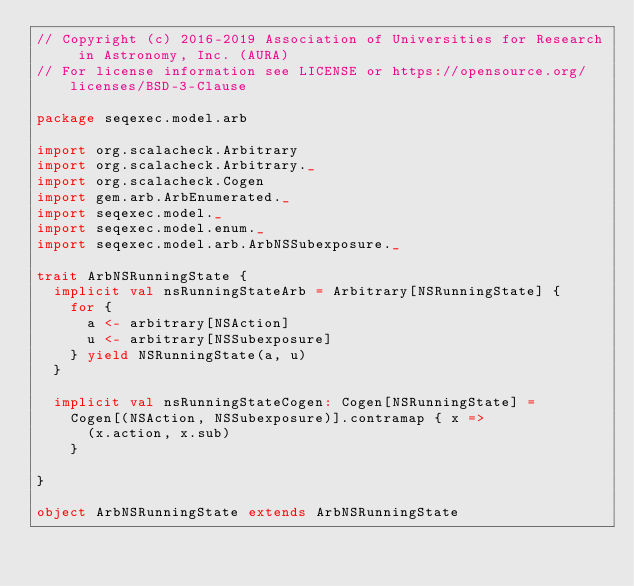Convert code to text. <code><loc_0><loc_0><loc_500><loc_500><_Scala_>// Copyright (c) 2016-2019 Association of Universities for Research in Astronomy, Inc. (AURA)
// For license information see LICENSE or https://opensource.org/licenses/BSD-3-Clause

package seqexec.model.arb

import org.scalacheck.Arbitrary
import org.scalacheck.Arbitrary._
import org.scalacheck.Cogen
import gem.arb.ArbEnumerated._
import seqexec.model._
import seqexec.model.enum._
import seqexec.model.arb.ArbNSSubexposure._

trait ArbNSRunningState {
  implicit val nsRunningStateArb = Arbitrary[NSRunningState] {
    for {
      a <- arbitrary[NSAction]
      u <- arbitrary[NSSubexposure]
    } yield NSRunningState(a, u)
  }

  implicit val nsRunningStateCogen: Cogen[NSRunningState] =
    Cogen[(NSAction, NSSubexposure)].contramap { x =>
      (x.action, x.sub)
    }

}

object ArbNSRunningState extends ArbNSRunningState
</code> 